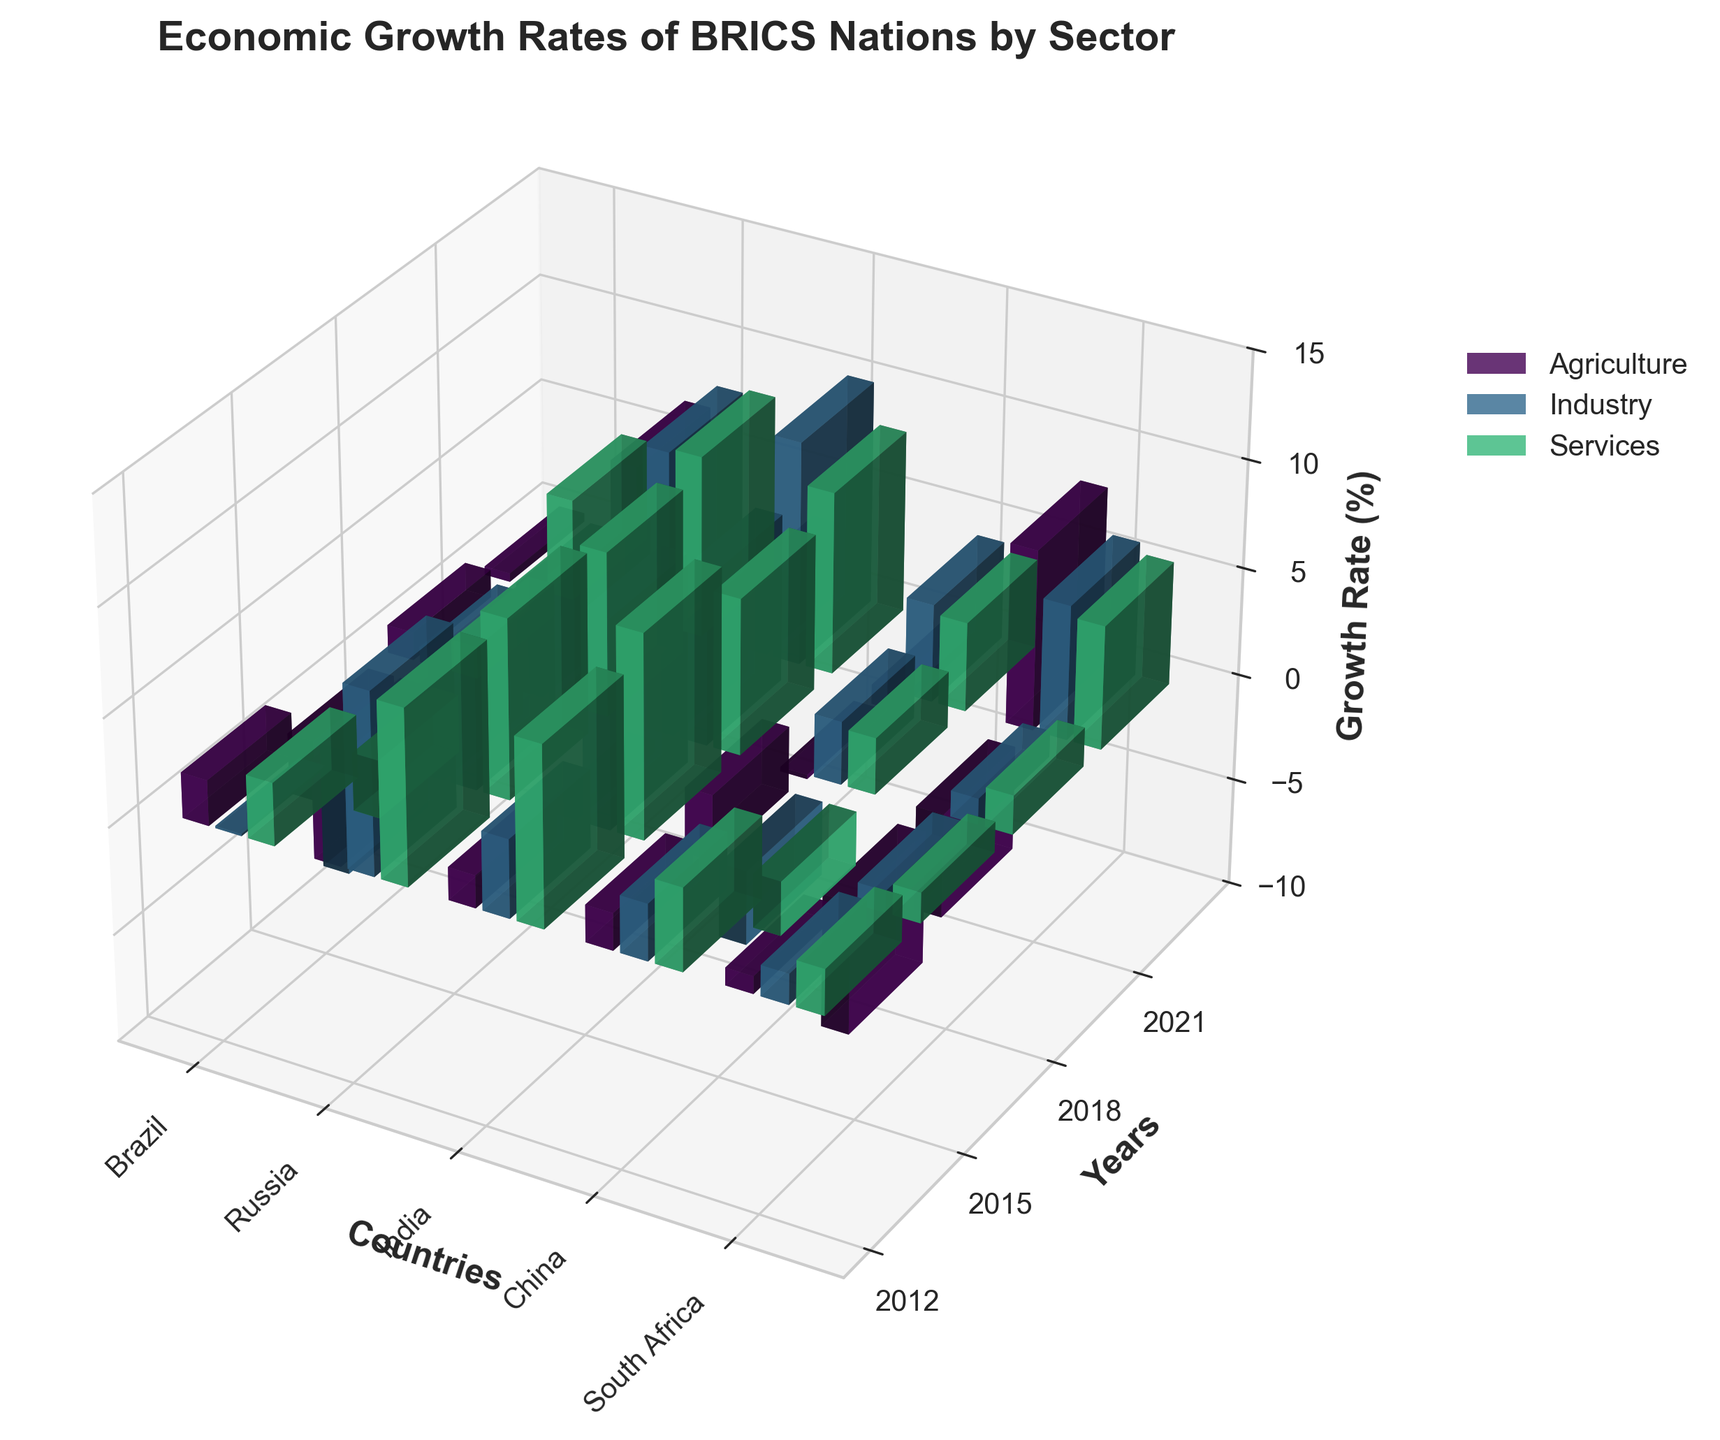What is the title of the figure? The title is usually indicated at the top of the figure in bold. In this case, it shows "Economic Growth Rates of BRICS Nations by Sector."
Answer: Economic Growth Rates of BRICS Nations by Sector Which country had the highest growth rate in the agriculture sector in 2021? To find the highest growth rate in the agriculture sector in 2021, look for the tallest bar in that year for the agriculture sector, which should be highlighted distinctly.
Answer: South Africa How did India's industrial growth rate change from 2012 to 2021? Check the height of the bars representing India's industrial sector for the years 2012 and 2021. Compare their heights to understand the change.
Answer: Increased Compare Brazil's economic growth rates in the industry sector for the years 2015 and 2021. Which year was worse? Observe the height of the bars representing Brazil's industry sector for both years. The bar with the lesser height or negative height indicates a worse economic performance.
Answer: 2015 What was the average growth rate of China's services sector across all the years represented? Add the height values of the bars for China's services sector from 2012, 2015, 2018, and 2021, and divide by the number of years.
Answer: (8.1 + 8.3 + 7.6 + 8.4) / 4 = 8.1 Which country experienced the lowest growth rate in the agriculture sector in 2015? Look for the shortest or most negative bar for the agriculture sector in 2015.
Answer: South Africa How did the service sector growth rate in Brazil change between 2015 and 2018? Compare the bar heights for Brazil's services sector between these two years. Determine if the bar height increased, decreased, or remained the same.
Answer: Increased In which year did South Africa experience its highest growth rate in any sector, and what was the sector? Identify the tallest bar among all the sectors for South Africa across all years. Determine the year and the corresponding sector.
Answer: 2021, Agriculture What is the combined growth rate of Russia's industry sector for the years 2015 and 2018? Add the heights of the bars representing Russia's industry sector for both years.
Answer: -3.4 + 2.9 = -0.5 Between 2018 and 2021, did China's growth rate in the industry sector increase or decrease? Compare the height of the bars representing the industry sector for China in the years 2018 and 2021.
Answer: Increased 